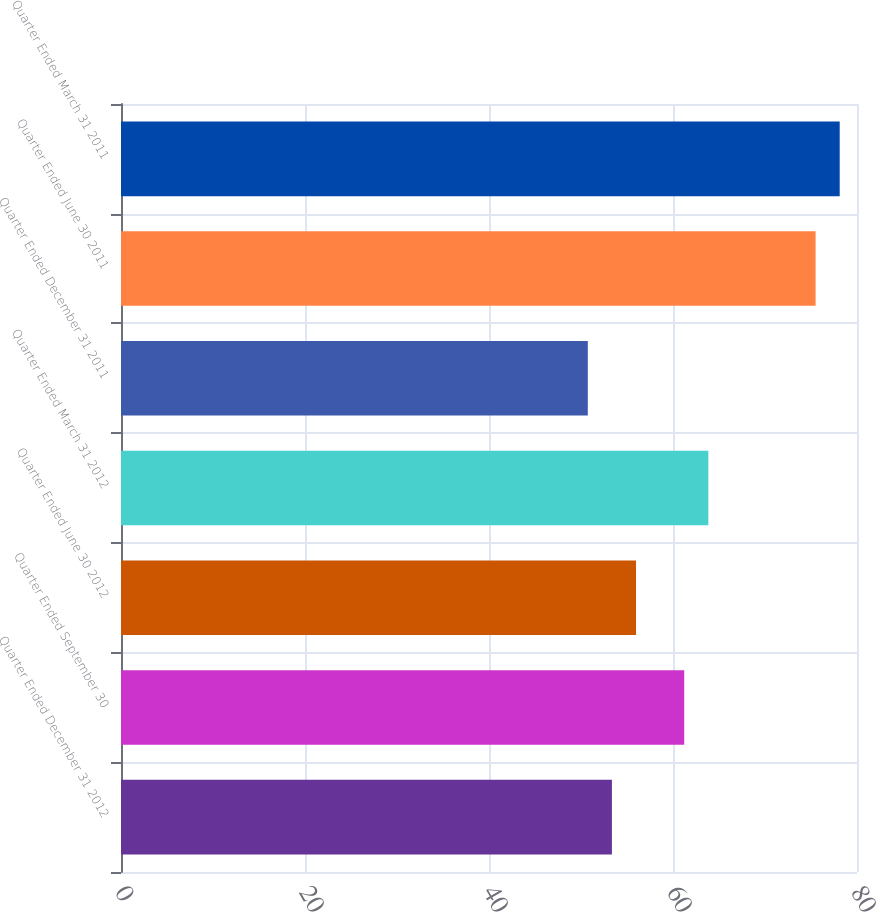Convert chart to OTSL. <chart><loc_0><loc_0><loc_500><loc_500><bar_chart><fcel>Quarter Ended December 31 2012<fcel>Quarter Ended September 30<fcel>Quarter Ended June 30 2012<fcel>Quarter Ended March 31 2012<fcel>Quarter Ended December 31 2011<fcel>Quarter Ended June 30 2011<fcel>Quarter Ended March 31 2011<nl><fcel>53.36<fcel>61.22<fcel>55.98<fcel>63.84<fcel>50.74<fcel>75.5<fcel>78.12<nl></chart> 